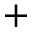<formula> <loc_0><loc_0><loc_500><loc_500>+</formula> 